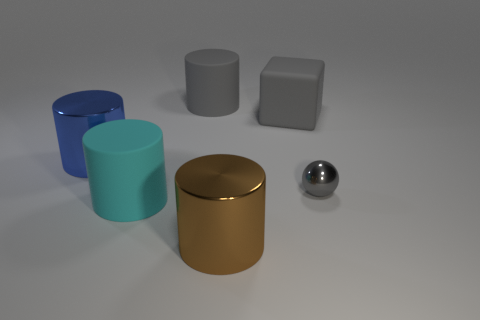Can you describe the lighting in the scene? The lighting appears to be coming from above, given the position of shadows underneath the objects. It seems diffuse, with a soft shadow indicating an overcast or studio light scenario. There are also subtle reflections on the objects that hint at where the light source might be located. 